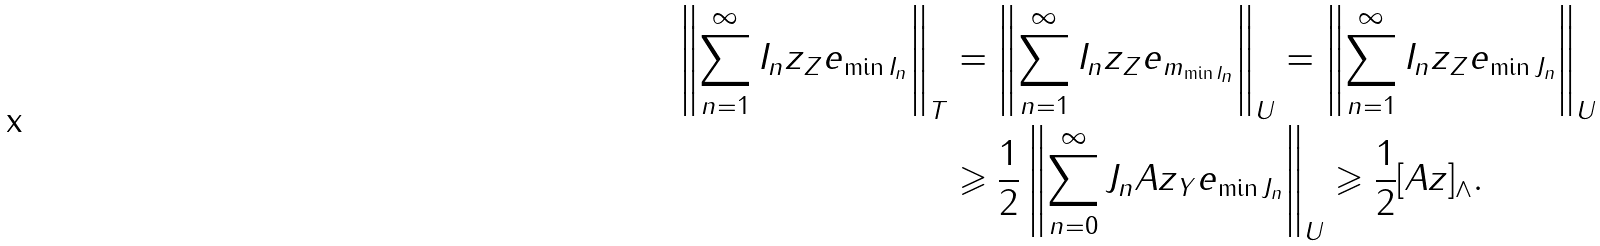Convert formula to latex. <formula><loc_0><loc_0><loc_500><loc_500>\left \| \sum _ { n = 1 } ^ { \infty } \| I _ { n } z \| _ { Z } e _ { \min I _ { n } } \right \| _ { T } & = \left \| \sum _ { n = 1 } ^ { \infty } \| I _ { n } z \| _ { Z } e _ { m _ { \min I _ { n } } } \right \| _ { U } = \left \| \sum _ { n = 1 } ^ { \infty } \| I _ { n } z \| _ { Z } e _ { \min J _ { n } } \right \| _ { U } \\ & \geqslant \frac { 1 } { 2 } \left \| \sum _ { n = 0 } ^ { \infty } \| J _ { n } A z \| _ { Y } e _ { \min J _ { n } } \right \| _ { U } \geqslant \frac { 1 } { 2 } [ A z ] _ { \wedge } .</formula> 